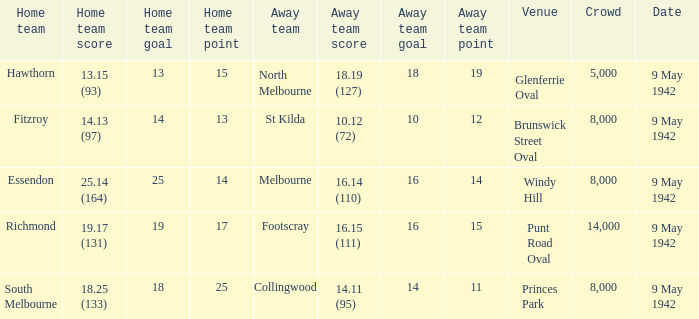How many people attended the game with the home team scoring 18.25 (133)? 1.0. 